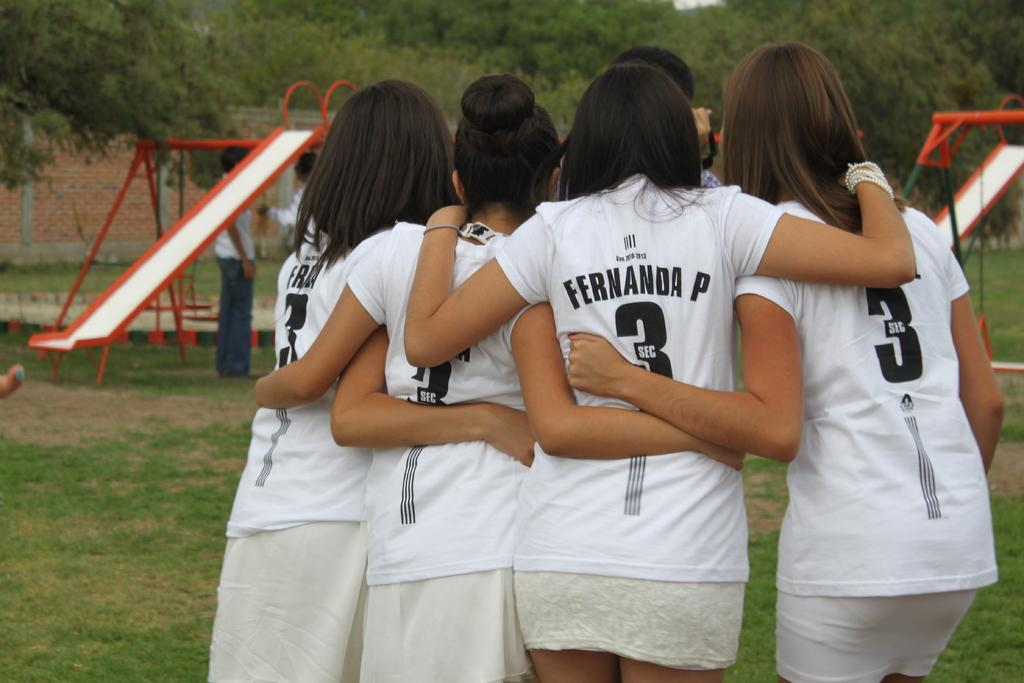<image>
Provide a brief description of the given image. Girls taking a photo with one girl whose shirt says Fernanda. 